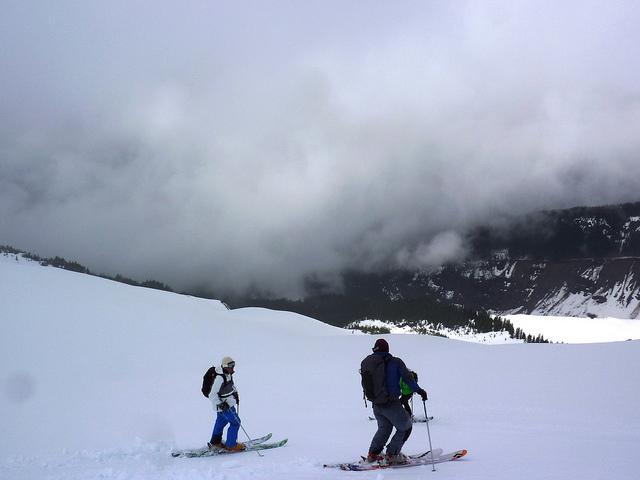What are the people doing?
Write a very short answer. Skiing. How many people are in this picture?
Be succinct. 3. Are they skiing?
Write a very short answer. Yes. 